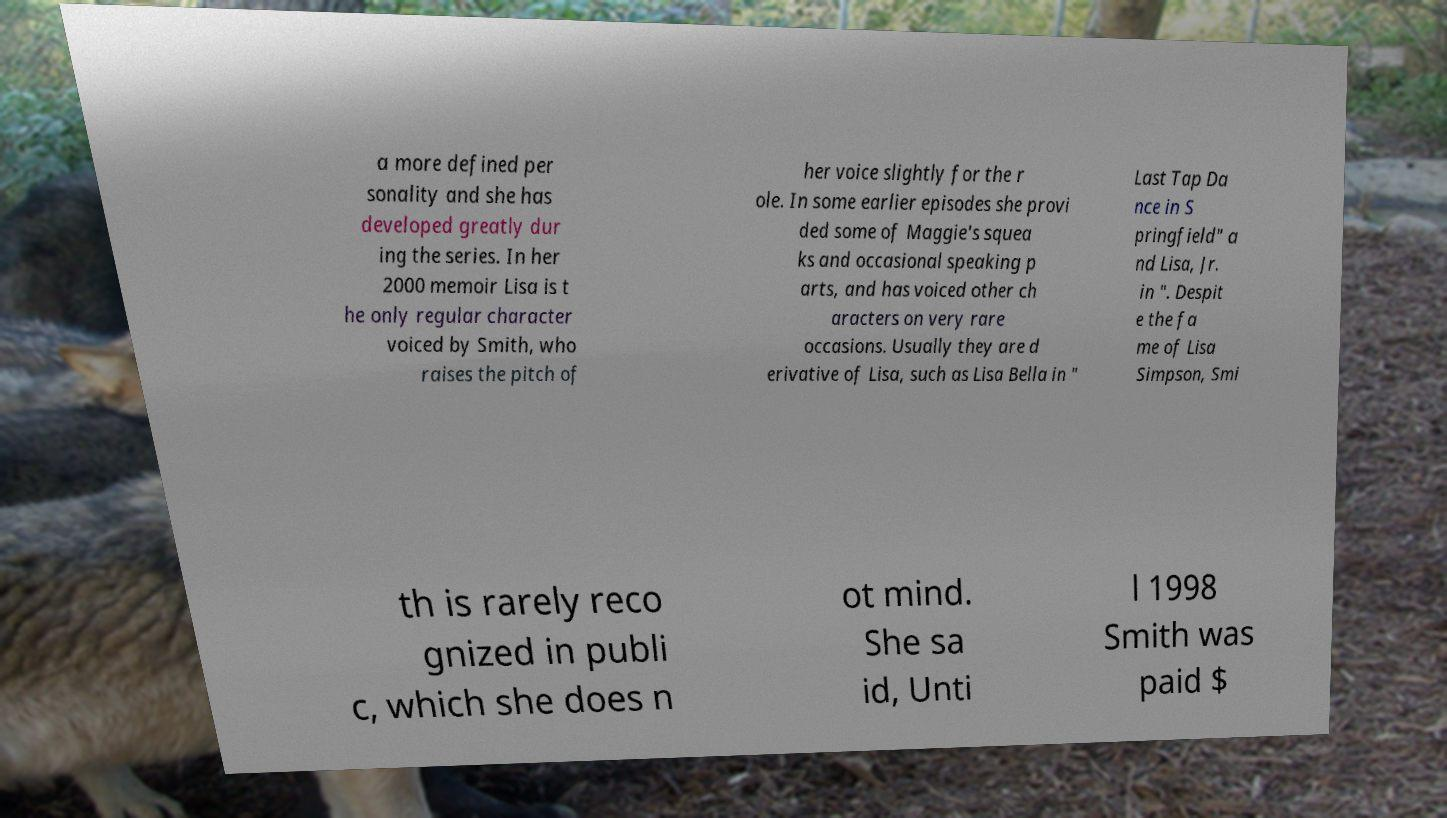I need the written content from this picture converted into text. Can you do that? a more defined per sonality and she has developed greatly dur ing the series. In her 2000 memoir Lisa is t he only regular character voiced by Smith, who raises the pitch of her voice slightly for the r ole. In some earlier episodes she provi ded some of Maggie's squea ks and occasional speaking p arts, and has voiced other ch aracters on very rare occasions. Usually they are d erivative of Lisa, such as Lisa Bella in " Last Tap Da nce in S pringfield" a nd Lisa, Jr. in ". Despit e the fa me of Lisa Simpson, Smi th is rarely reco gnized in publi c, which she does n ot mind. She sa id, Unti l 1998 Smith was paid $ 